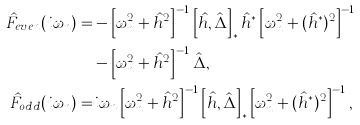Convert formula to latex. <formula><loc_0><loc_0><loc_500><loc_500>\hat { F } _ { e v e n } ( i \omega _ { n } ) = & - \left [ \omega _ { n } ^ { 2 } + \hat { h } ^ { 2 } \right ] ^ { - 1 } \left [ \hat { h } , \hat { \Delta } \right ] _ { * } \hat { h } ^ { * } \left [ \omega _ { n } ^ { 2 } + ( \hat { h } ^ { * } ) ^ { 2 } \right ] ^ { - 1 } \\ & - \left [ \omega _ { n } ^ { 2 } + \hat { h } ^ { 2 } \right ] ^ { - 1 } \hat { \Delta } , \\ \hat { F } _ { o d d } ( i \omega _ { n } ) = & i \omega _ { n } \left [ \omega _ { n } ^ { 2 } + \hat { h } ^ { 2 } \right ] ^ { - 1 } \left [ \hat { h } , \hat { \Delta } \right ] _ { * } \left [ \omega _ { n } ^ { 2 } + ( \hat { h } ^ { * } ) ^ { 2 } \right ] ^ { - 1 } ,</formula> 